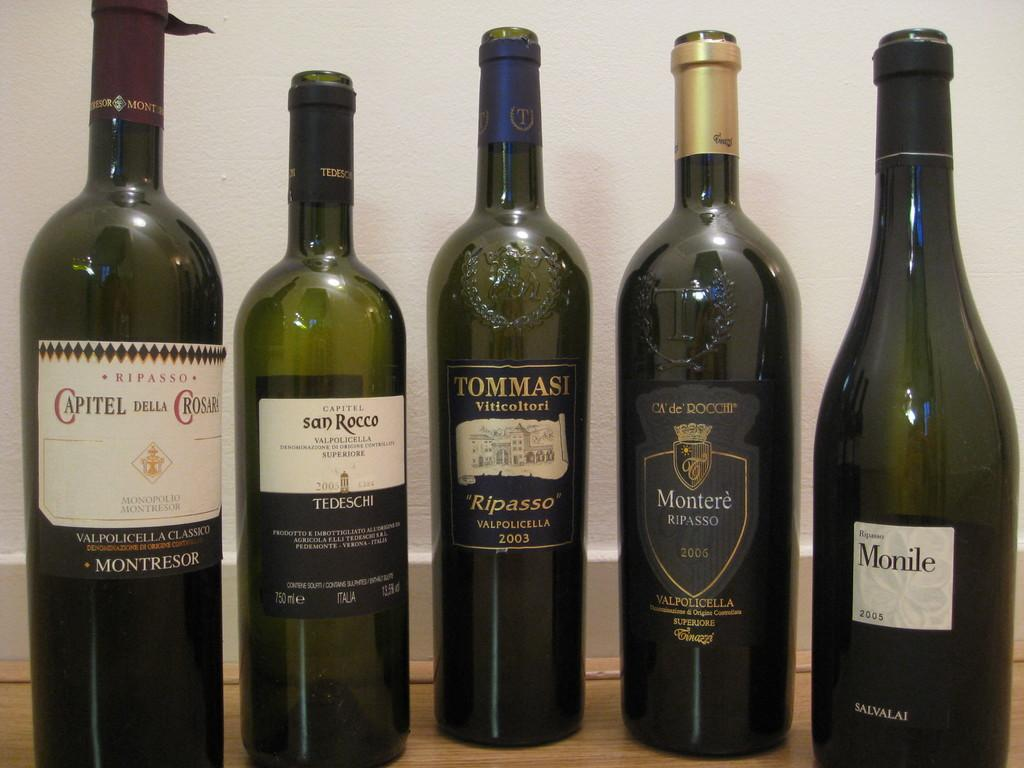Provide a one-sentence caption for the provided image. Five bottles of wine, Monile is the last bottle of the right. 